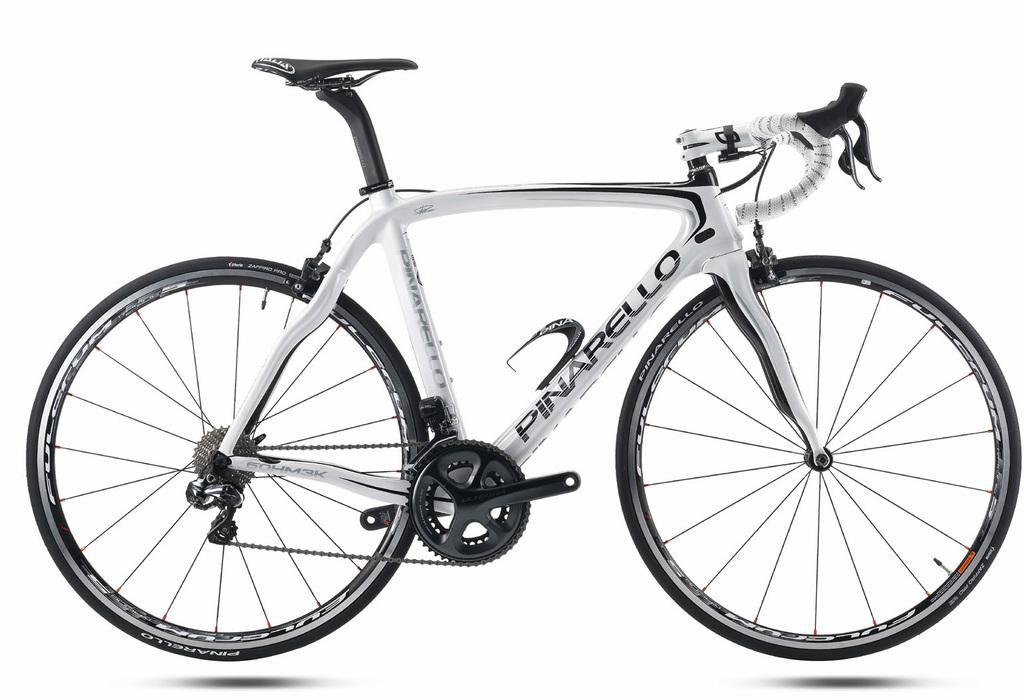Could you give a brief overview of what you see in this image? In the picture I can see a bicycle which has something written on it. The background of the image is white in color. 